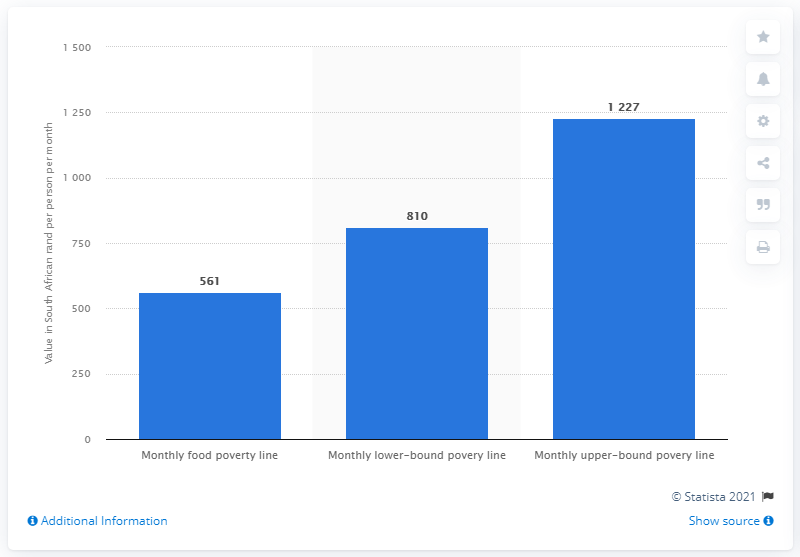Indicate a few pertinent items in this graphic. As of 2019, there were 561 Rand available for food in South Africa. 